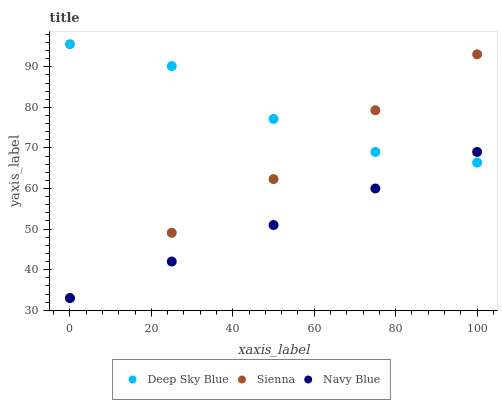Does Navy Blue have the minimum area under the curve?
Answer yes or no. Yes. Does Deep Sky Blue have the maximum area under the curve?
Answer yes or no. Yes. Does Deep Sky Blue have the minimum area under the curve?
Answer yes or no. No. Does Navy Blue have the maximum area under the curve?
Answer yes or no. No. Is Navy Blue the smoothest?
Answer yes or no. Yes. Is Deep Sky Blue the roughest?
Answer yes or no. Yes. Is Deep Sky Blue the smoothest?
Answer yes or no. No. Is Navy Blue the roughest?
Answer yes or no. No. Does Sienna have the lowest value?
Answer yes or no. Yes. Does Deep Sky Blue have the lowest value?
Answer yes or no. No. Does Deep Sky Blue have the highest value?
Answer yes or no. Yes. Does Navy Blue have the highest value?
Answer yes or no. No. Does Deep Sky Blue intersect Sienna?
Answer yes or no. Yes. Is Deep Sky Blue less than Sienna?
Answer yes or no. No. Is Deep Sky Blue greater than Sienna?
Answer yes or no. No. 